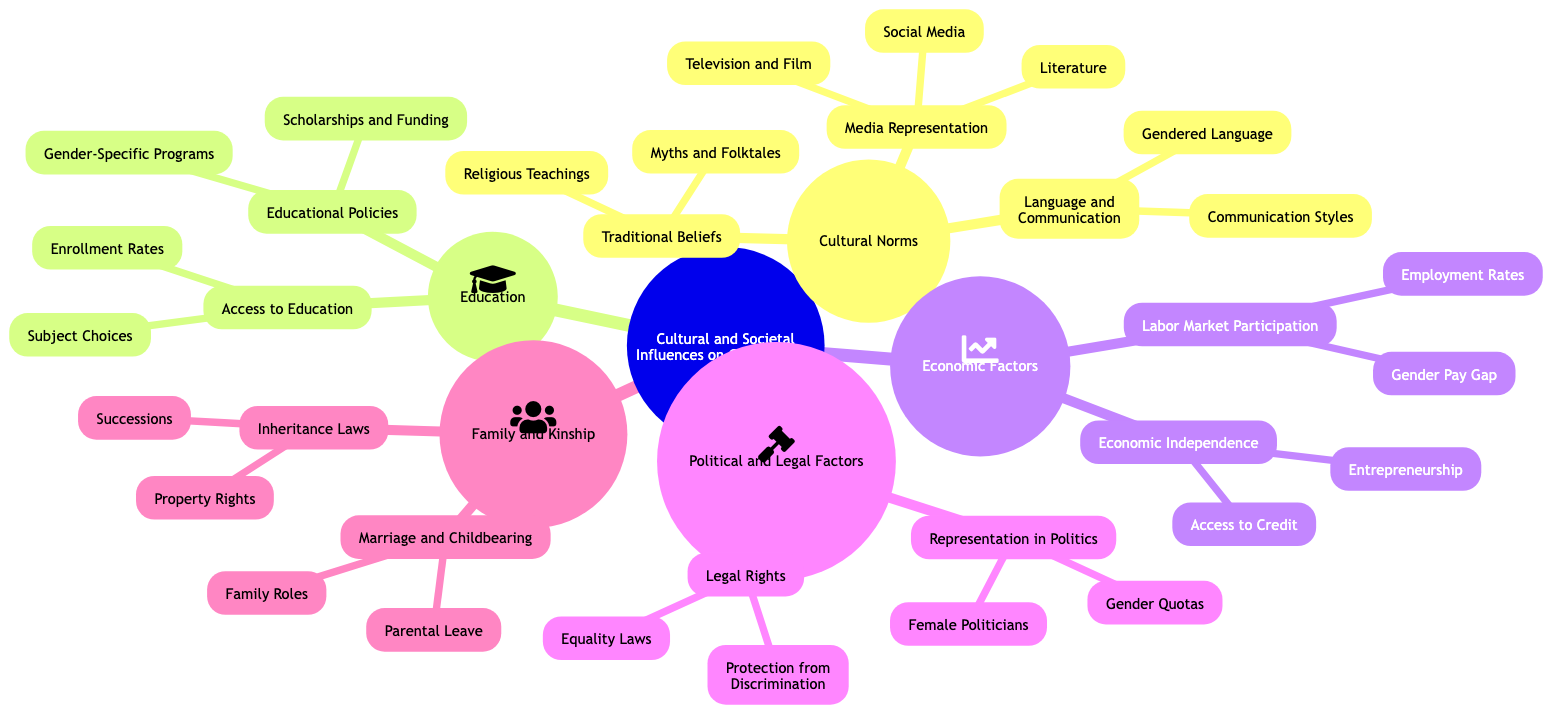What are the main branches of the diagram? The main branches visible in the diagram are Cultural Norms, Education, Economic Factors, Political and Legal Factors, and Family and Kinship.
Answer: Cultural Norms, Education, Economic Factors, Political and Legal Factors, Family and Kinship How many sub-branches does "Labor Market Participation" have? "Labor Market Participation" has two sub-branches: Employment Rates and Gender Pay Gap.
Answer: 2 What type of factors does "Educational Policies" fall under? "Educational Policies" is categorized under the Education branch, which focuses on education-related aspects.
Answer: Education Which branch includes "Female Politicians"? "Female Politicians" is included in the Political and Legal Factors branch.
Answer: Political and Legal Factors Explain the relationship between "Media Representation" and "Social Media". "Media Representation" is a sub-branch of "Cultural Norms", and "Social Media" is a sub-branch under "Media Representation," showing how social media influences gender roles through media representation.
Answer: Media Representation > Social Media What is the total number of sub-branches under "Marriage and Childbearing"? The total number of sub-branches under "Marriage and Childbearing" is two: Family Roles and Parental Leave.
Answer: 2 Which factor is associated with "Gender-Specific Programs"? "Gender-Specific Programs" is associated with the Educational Policies sub-branch of the Education branch.
Answer: Educational Policies Name one economic aspect that connects to gender roles depicted in the diagram. One economic aspect that connects to gender roles is the Gender Pay Gap, which is a sub-branch of Labor Market Participation.
Answer: Gender Pay Gap In which branch would you find "Inheritance Laws"? "Inheritance Laws" is found in the Family and Kinship branch, focusing on laws related to family and inheritance.
Answer: Family and Kinship 